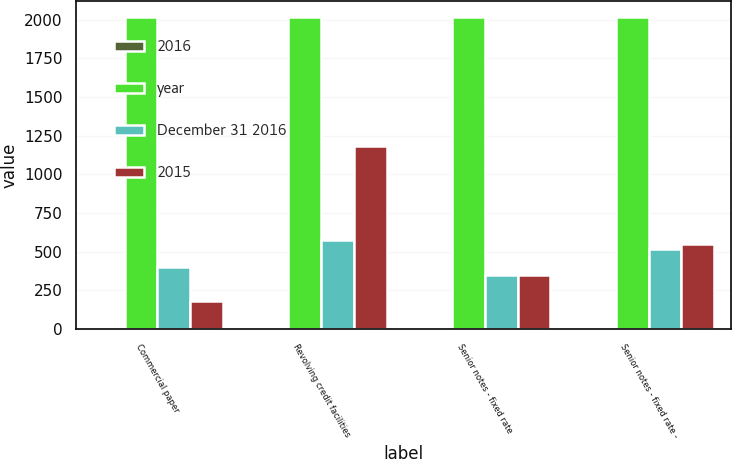Convert chart to OTSL. <chart><loc_0><loc_0><loc_500><loc_500><stacked_bar_chart><ecel><fcel>Commercial paper<fcel>Revolving credit facilities<fcel>Senior notes - fixed rate<fcel>Senior notes - fixed rate -<nl><fcel>2016<fcel>1.75<fcel>2.19<fcel>1.88<fcel>2.45<nl><fcel>year<fcel>2019<fcel>2019<fcel>2017<fcel>2019<nl><fcel>December 31 2016<fcel>398.7<fcel>576.8<fcel>350<fcel>520.7<nl><fcel>2015<fcel>179.5<fcel>1181.4<fcel>350<fcel>548.4<nl></chart> 